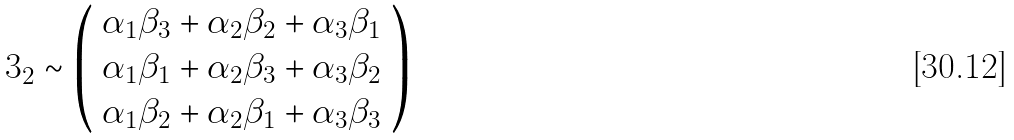Convert formula to latex. <formula><loc_0><loc_0><loc_500><loc_500>3 _ { 2 } \sim \left ( \begin{array} { c } \alpha _ { 1 } \beta _ { 3 } + \alpha _ { 2 } \beta _ { 2 } + \alpha _ { 3 } \beta _ { 1 } \\ \alpha _ { 1 } \beta _ { 1 } + \alpha _ { 2 } \beta _ { 3 } + \alpha _ { 3 } \beta _ { 2 } \\ \alpha _ { 1 } \beta _ { 2 } + \alpha _ { 2 } \beta _ { 1 } + \alpha _ { 3 } \beta _ { 3 } \end{array} \right )</formula> 